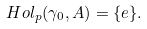Convert formula to latex. <formula><loc_0><loc_0><loc_500><loc_500>H o l _ { p } ( \gamma _ { 0 } , A ) = \{ e \} .</formula> 